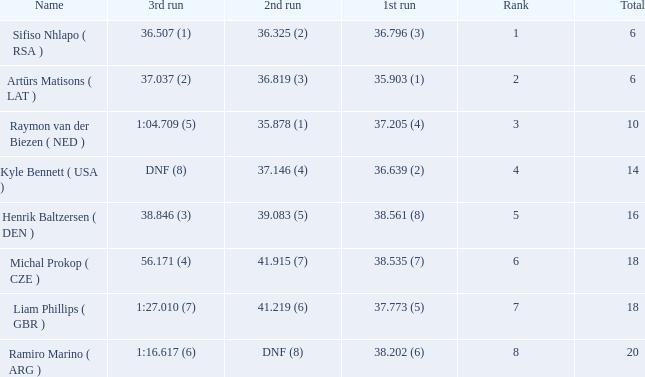Write the full table. {'header': ['Name', '3rd run', '2nd run', '1st run', 'Rank', 'Total'], 'rows': [['Sifiso Nhlapo ( RSA )', '36.507 (1)', '36.325 (2)', '36.796 (3)', '1', '6'], ['Artūrs Matisons ( LAT )', '37.037 (2)', '36.819 (3)', '35.903 (1)', '2', '6'], ['Raymon van der Biezen ( NED )', '1:04.709 (5)', '35.878 (1)', '37.205 (4)', '3', '10'], ['Kyle Bennett ( USA )', 'DNF (8)', '37.146 (4)', '36.639 (2)', '4', '14'], ['Henrik Baltzersen ( DEN )', '38.846 (3)', '39.083 (5)', '38.561 (8)', '5', '16'], ['Michal Prokop ( CZE )', '56.171 (4)', '41.915 (7)', '38.535 (7)', '6', '18'], ['Liam Phillips ( GBR )', '1:27.010 (7)', '41.219 (6)', '37.773 (5)', '7', '18'], ['Ramiro Marino ( ARG )', '1:16.617 (6)', 'DNF (8)', '38.202 (6)', '8', '20']]} Which 3rd run has rank of 8? 1:16.617 (6). 